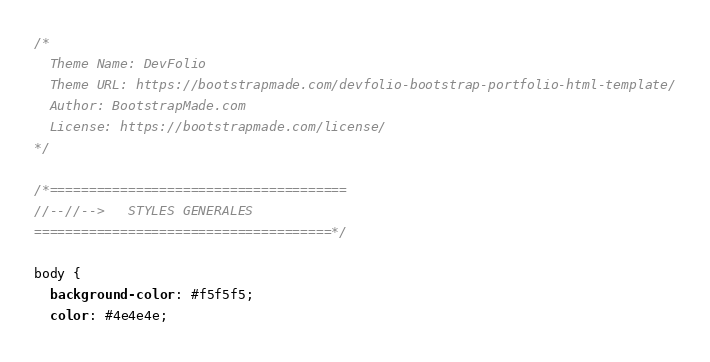Convert code to text. <code><loc_0><loc_0><loc_500><loc_500><_CSS_>/*
  Theme Name: DevFolio
  Theme URL: https://bootstrapmade.com/devfolio-bootstrap-portfolio-html-template/
  Author: BootstrapMade.com
  License: https://bootstrapmade.com/license/
*/

/*======================================
//--//-->   STYLES GENERALES
======================================*/

body {
  background-color: #f5f5f5;
  color: #4e4e4e;</code> 